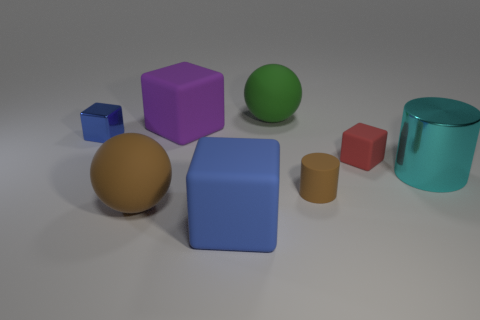Subtract 1 blocks. How many blocks are left? 3 Subtract all brown cubes. Subtract all purple cylinders. How many cubes are left? 4 Add 1 red cubes. How many objects exist? 9 Subtract all spheres. How many objects are left? 6 Subtract 0 purple balls. How many objects are left? 8 Subtract all big blocks. Subtract all blue cubes. How many objects are left? 4 Add 2 shiny objects. How many shiny objects are left? 4 Add 3 cyan spheres. How many cyan spheres exist? 3 